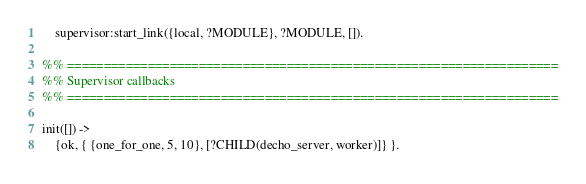<code> <loc_0><loc_0><loc_500><loc_500><_Erlang_>    supervisor:start_link({local, ?MODULE}, ?MODULE, []).

%% ===================================================================
%% Supervisor callbacks
%% ===================================================================

init([]) ->
    {ok, { {one_for_one, 5, 10}, [?CHILD(decho_server, worker)]} }.

</code> 